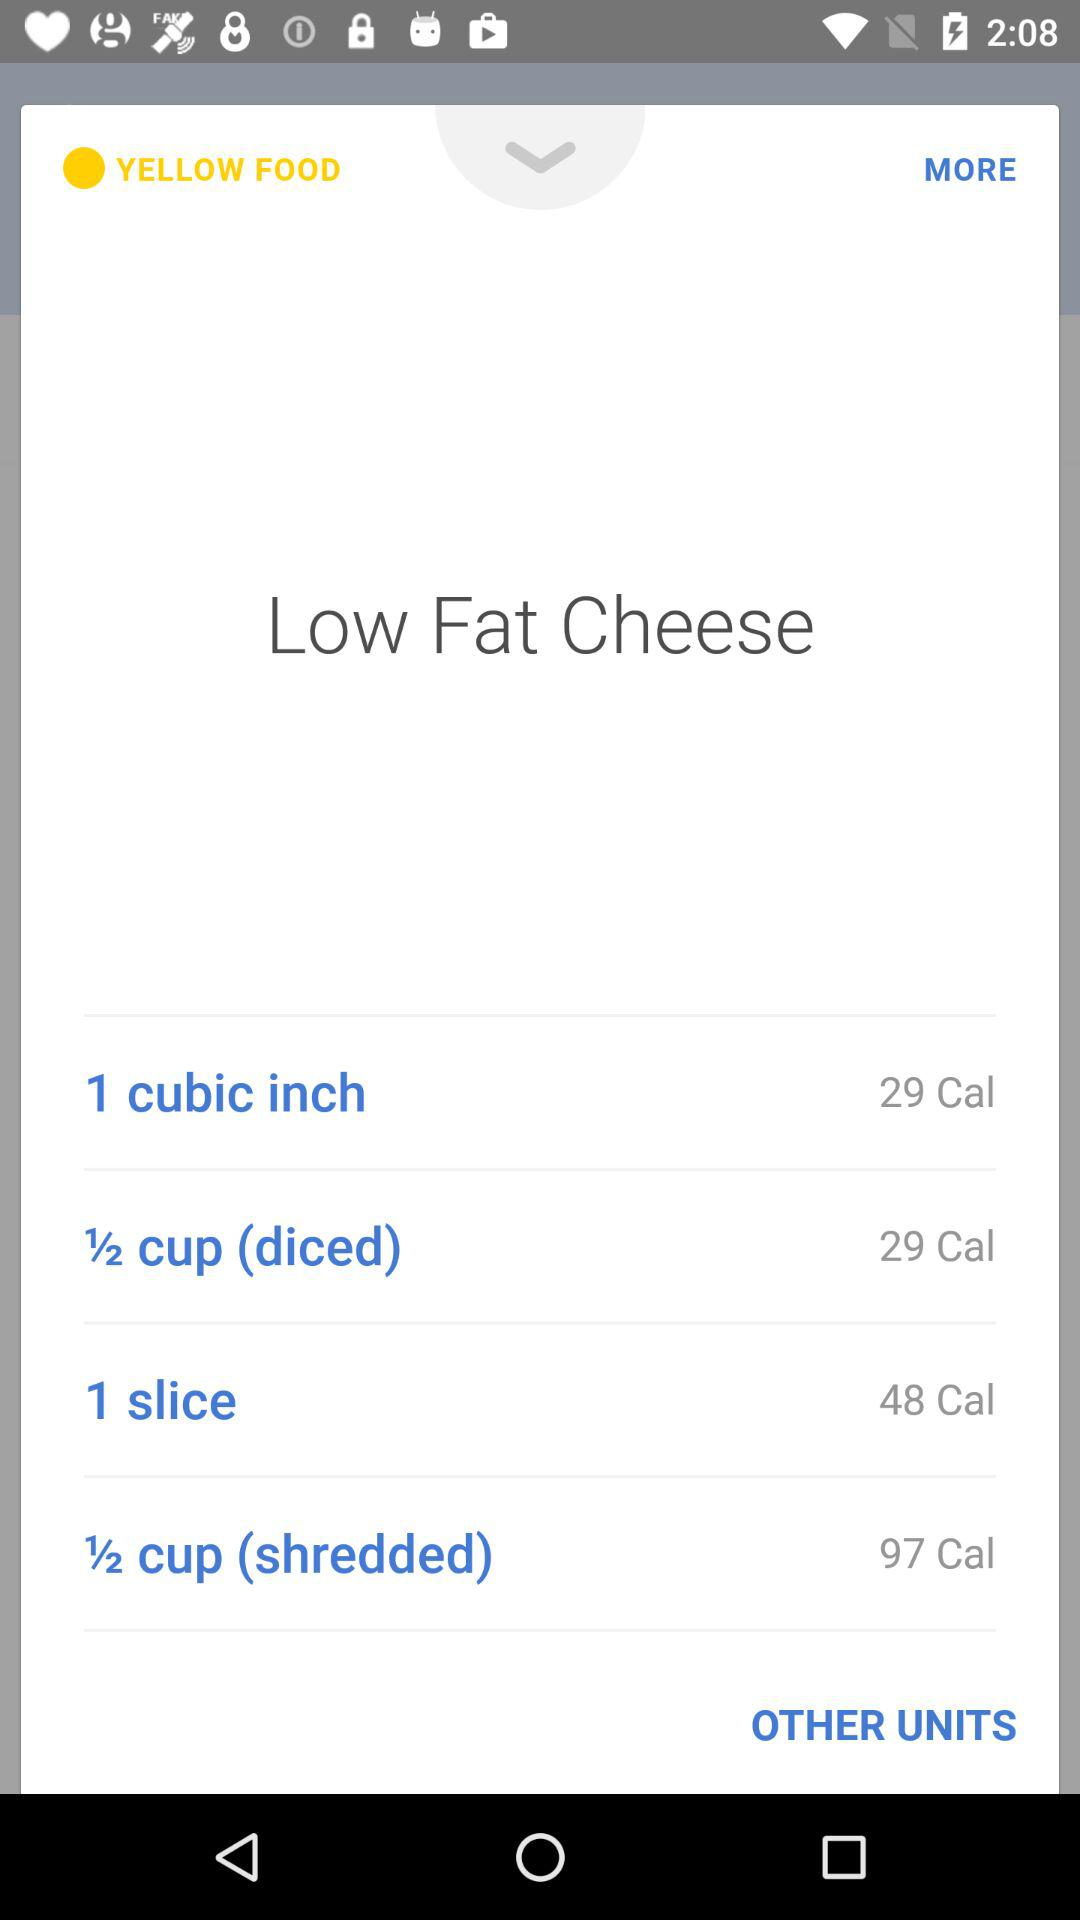What is the amount of calorie present in 1 slice? The amount of calories is 48. 